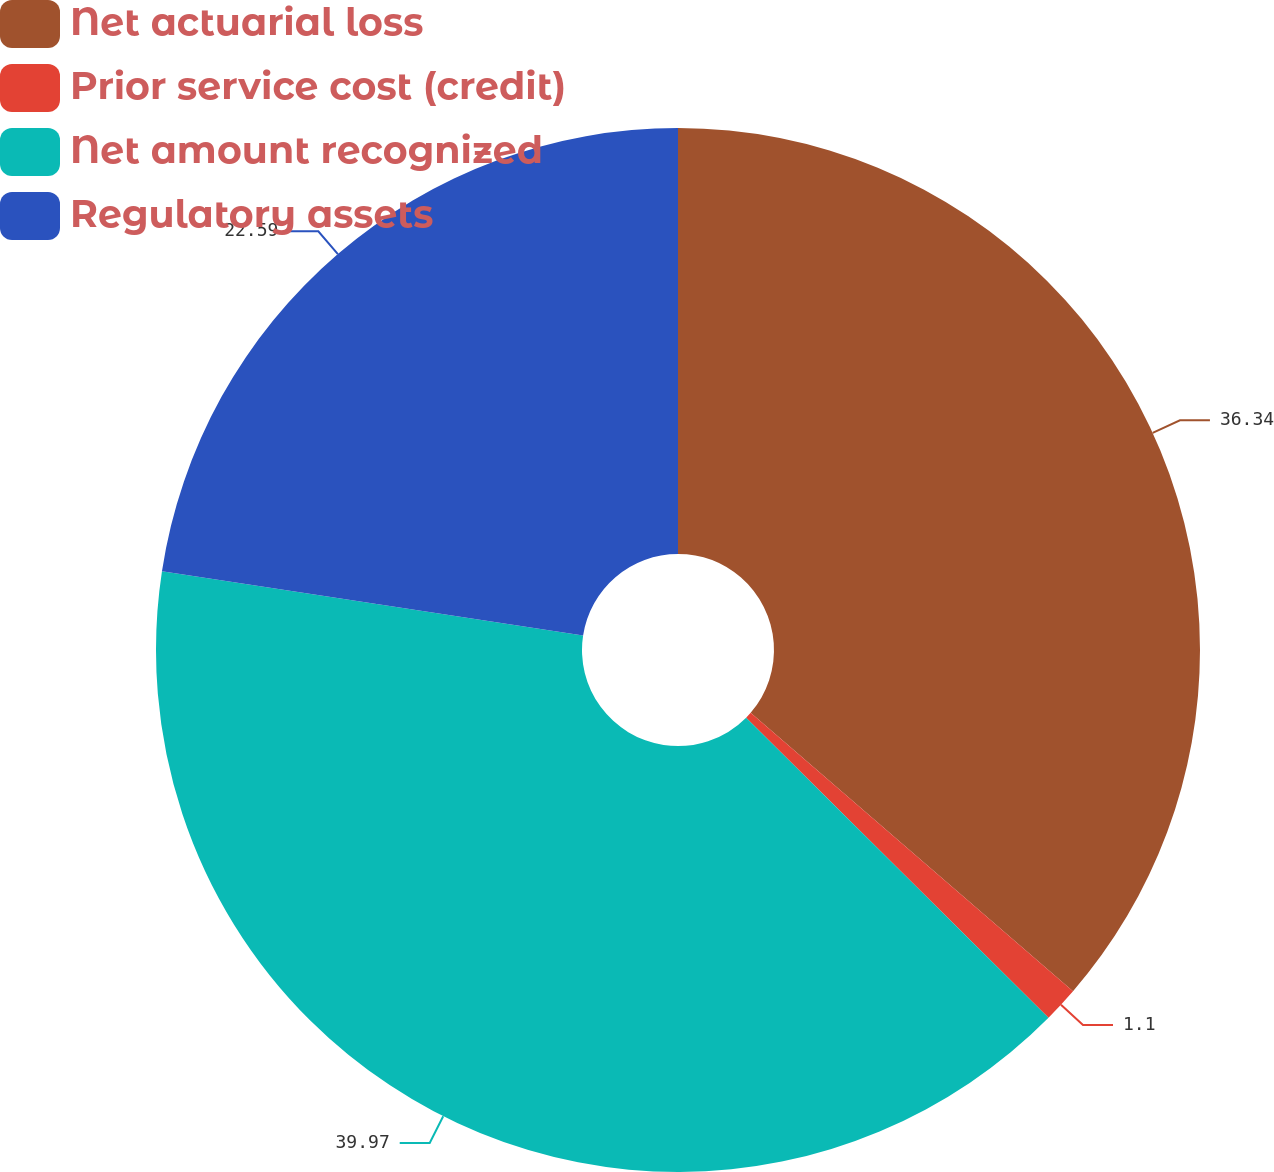Convert chart. <chart><loc_0><loc_0><loc_500><loc_500><pie_chart><fcel>Net actuarial loss<fcel>Prior service cost (credit)<fcel>Net amount recognized<fcel>Regulatory assets<nl><fcel>36.34%<fcel>1.1%<fcel>39.97%<fcel>22.59%<nl></chart> 